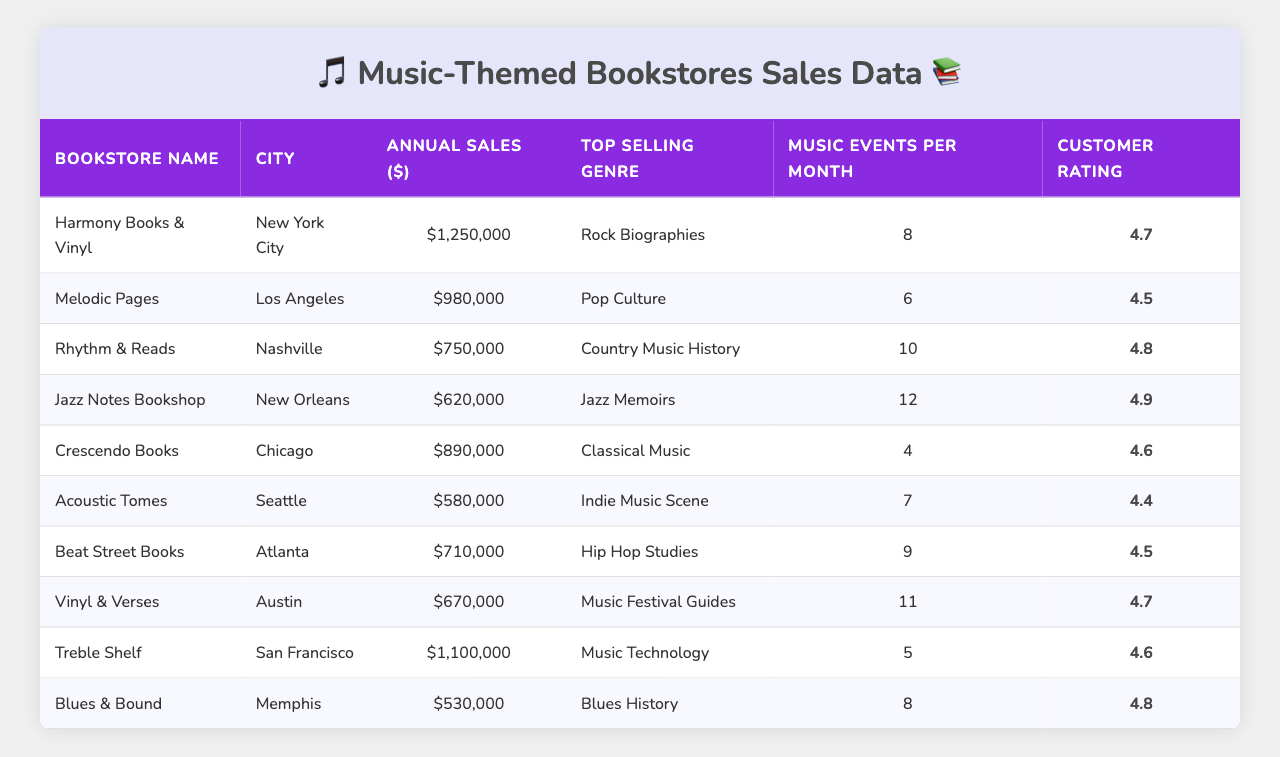What is the top selling genre at Rhythm & Reads? From the table, we can locate the row for Rhythm & Reads, which shows that the top selling genre is "Country Music History."
Answer: Country Music History Which city has the highest annual sales? By examining the Annual Sales column, Harmony Books & Vinyl in New York City has the highest sales at $1,250,000, compared to other stores.
Answer: New York City What is the average customer rating for the bookstores listed? To find the average customer rating, we sum all the ratings (4.7 + 4.5 + 4.8 + 4.9 + 4.6 + 4.4 + 4.5 + 4.7 + 4.6 + 4.8) which equals 46.5. Since there are 10 bookstores, the average is 46.5 / 10 = 4.65.
Answer: 4.65 How many music events per month does the bookstore with the lowest sales hold? The bookstore with the lowest annual sales is Blues & Bound in Memphis, which holds 8 music events per month.
Answer: 8 Is the customer rating for Treble Shelf higher than the average rating? The customer rating for Treble Shelf is 4.6. From our previous calculation, the average rating is 4.65. Since 4.6 is less than 4.65, therefore, Treble Shelf's rating is not higher.
Answer: No Which city has the second lowest annual sales and what is the amount? Reviewing the Annual Sales column, we find that Acoustic Tomes in Seattle has the second lowest sales at $580,000, with only Blues & Bound lower.
Answer: Seattle, $580,000 What is the total number of music events held per month across all bookstores? We add the music events per month for each bookstore (8 + 6 + 10 + 12 + 4 + 7 + 9 + 11 + 5 + 8) together, totaling 80 music events.
Answer: 80 Does Rhythm & Reads have a higher customer rating than Melodic Pages? Rhythm & Reads has a customer rating of 4.8 and Melodic Pages has 4.5. Since 4.8 is greater than 4.5, Rhythm & Reads does have a higher rating.
Answer: Yes What is the difference in annual sales between Harmony Books & Vinyl and Jazz Notes Bookshop? Harmony Books & Vinyl has sales of $1,250,000 and Jazz Notes Bookshop has $620,000. The difference is $1,250,000 - $620,000 = $630,000.
Answer: $630,000 Which bookstore sells Rock Biographies and what is its customer rating? The bookstore selling Rock Biographies is Harmony Books & Vinyl, and its customer rating is 4.7.
Answer: Harmony Books & Vinyl, 4.7 